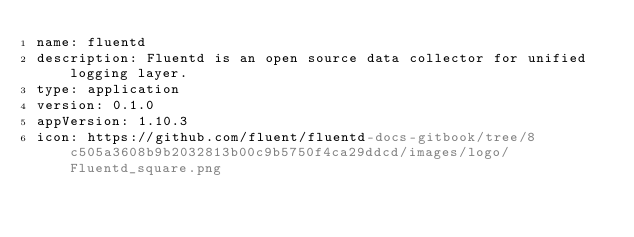<code> <loc_0><loc_0><loc_500><loc_500><_YAML_>name: fluentd
description: Fluentd is an open source data collector for unified logging layer.
type: application
version: 0.1.0
appVersion: 1.10.3
icon: https://github.com/fluent/fluentd-docs-gitbook/tree/8c505a3608b9b2032813b00c9b5750f4ca29ddcd/images/logo/Fluentd_square.png
</code> 